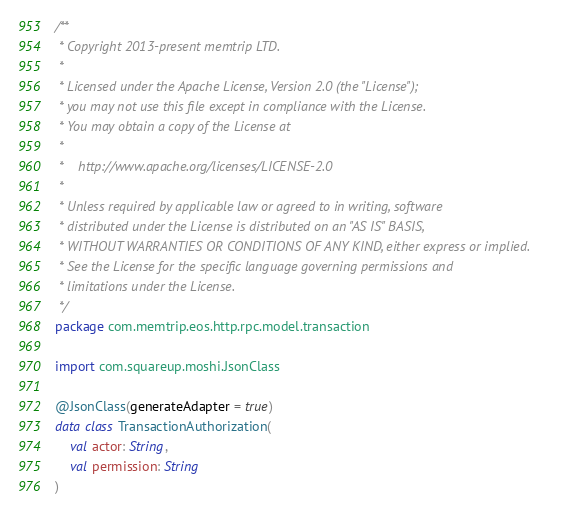Convert code to text. <code><loc_0><loc_0><loc_500><loc_500><_Kotlin_>/**
 * Copyright 2013-present memtrip LTD.
 *
 * Licensed under the Apache License, Version 2.0 (the "License");
 * you may not use this file except in compliance with the License.
 * You may obtain a copy of the License at
 *
 *    http://www.apache.org/licenses/LICENSE-2.0
 *
 * Unless required by applicable law or agreed to in writing, software
 * distributed under the License is distributed on an "AS IS" BASIS,
 * WITHOUT WARRANTIES OR CONDITIONS OF ANY KIND, either express or implied.
 * See the License for the specific language governing permissions and
 * limitations under the License.
 */
package com.memtrip.eos.http.rpc.model.transaction

import com.squareup.moshi.JsonClass

@JsonClass(generateAdapter = true)
data class TransactionAuthorization(
    val actor: String,
    val permission: String
)</code> 